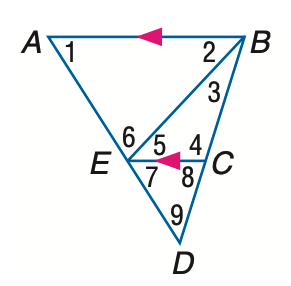Answer the mathemtical geometry problem and directly provide the correct option letter.
Question: In the figure, m \angle 1 = 58, m \angle 2 = 47, and m \angle 3 = 26. Find the measure of \angle 7.
Choices: A: 47 B: 49 C: 58 D: 73 C 